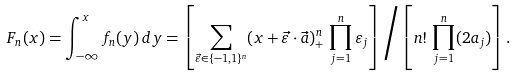<formula> <loc_0><loc_0><loc_500><loc_500>F _ { n } ( x ) = \int _ { - \infty } ^ { x } f _ { n } ( y ) \, d y = \left [ \sum _ { \vec { \varepsilon } \in \{ - 1 , 1 \} ^ { n } } ( x + \vec { \varepsilon } \cdot \vec { a } ) ^ { n } _ { + } \, \prod _ { j = 1 } ^ { n } \varepsilon _ { j } \right ] \Big / \left [ n ! \, \prod _ { j = 1 } ^ { n } ( 2 a _ { j } ) \right ] .</formula> 